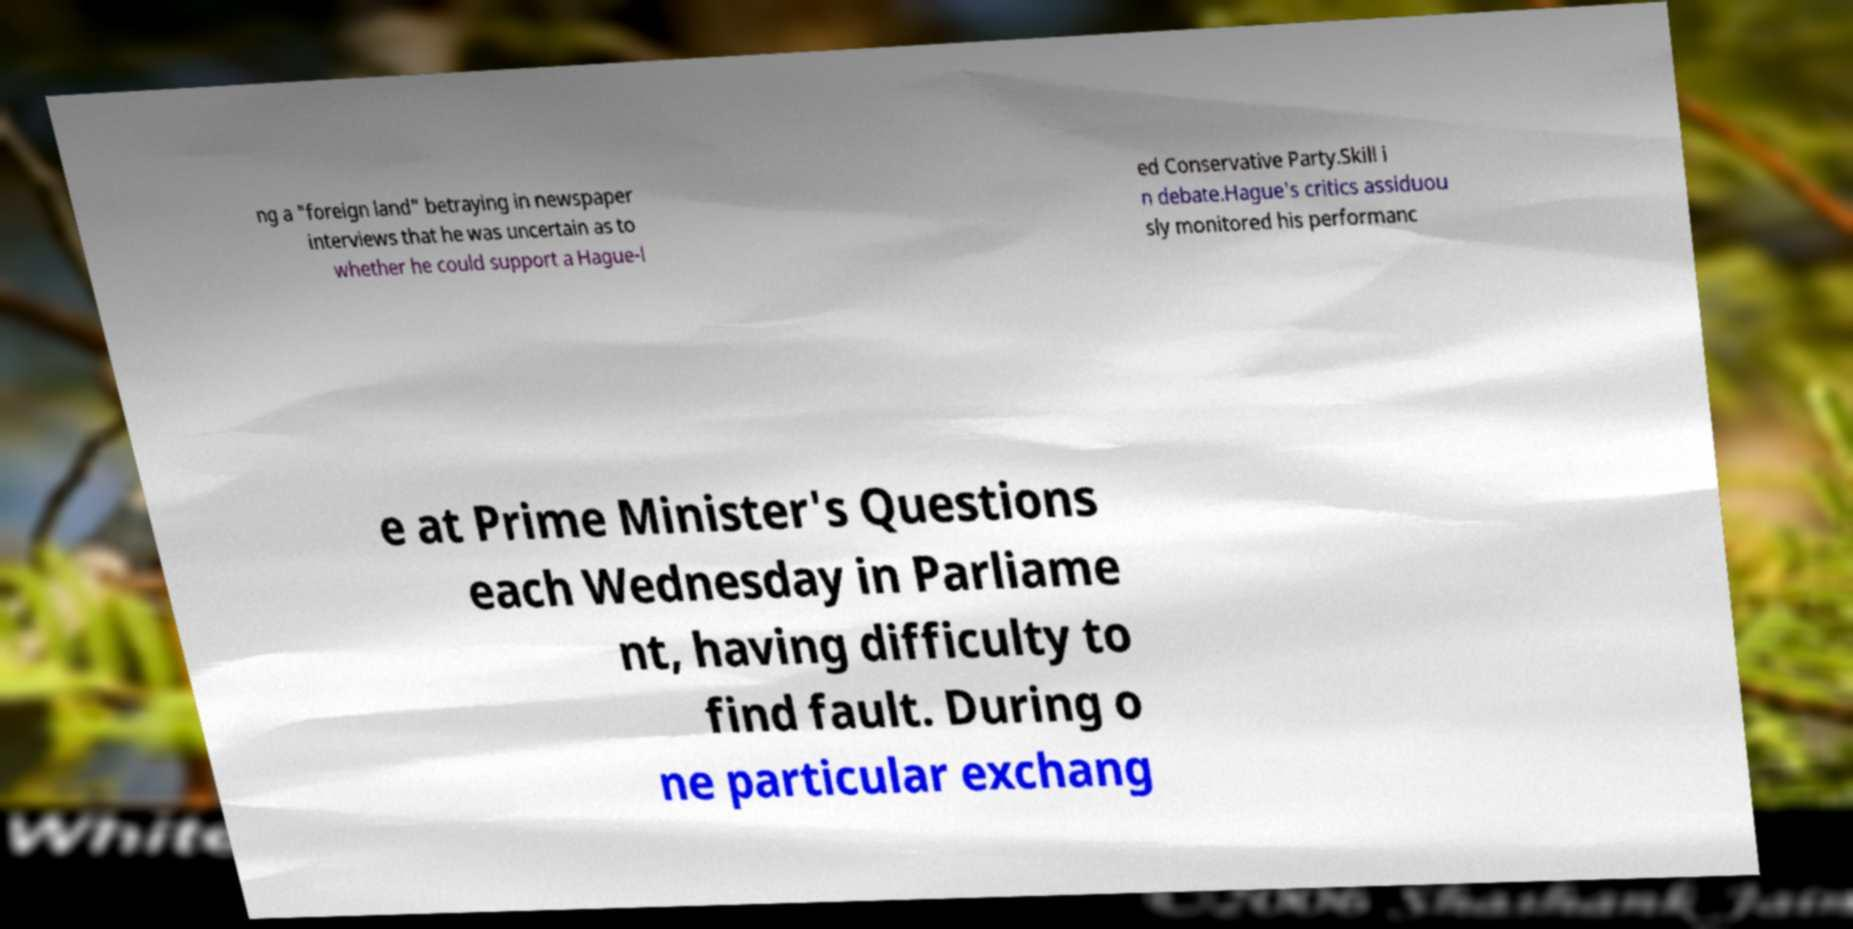What messages or text are displayed in this image? I need them in a readable, typed format. ng a "foreign land" betraying in newspaper interviews that he was uncertain as to whether he could support a Hague-l ed Conservative Party.Skill i n debate.Hague's critics assiduou sly monitored his performanc e at Prime Minister's Questions each Wednesday in Parliame nt, having difficulty to find fault. During o ne particular exchang 